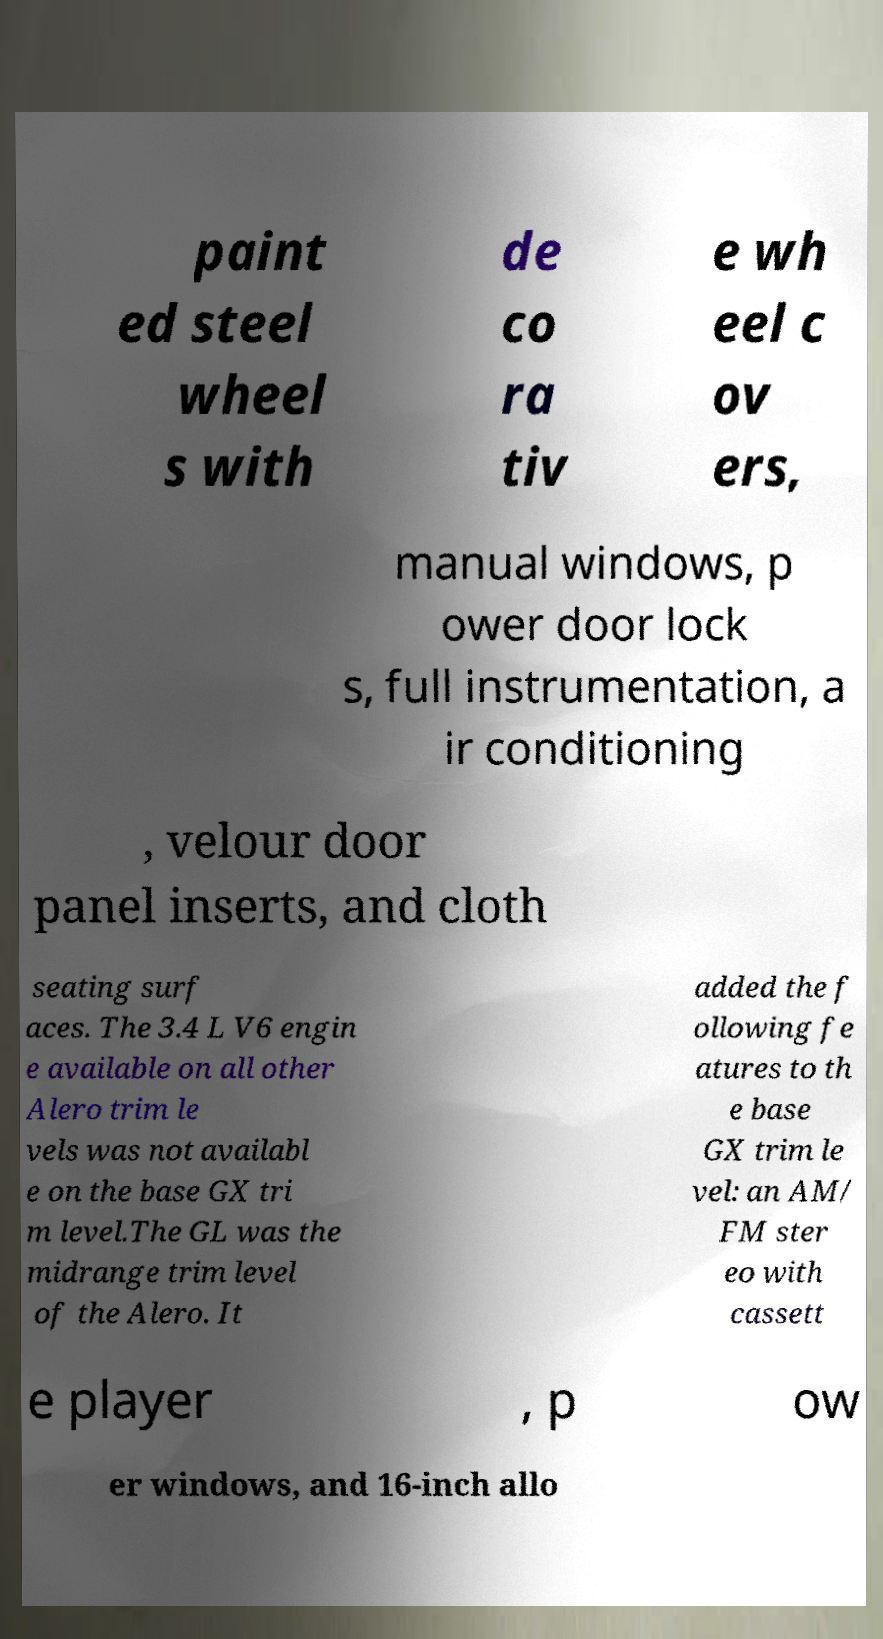Can you accurately transcribe the text from the provided image for me? paint ed steel wheel s with de co ra tiv e wh eel c ov ers, manual windows, p ower door lock s, full instrumentation, a ir conditioning , velour door panel inserts, and cloth seating surf aces. The 3.4 L V6 engin e available on all other Alero trim le vels was not availabl e on the base GX tri m level.The GL was the midrange trim level of the Alero. It added the f ollowing fe atures to th e base GX trim le vel: an AM/ FM ster eo with cassett e player , p ow er windows, and 16-inch allo 